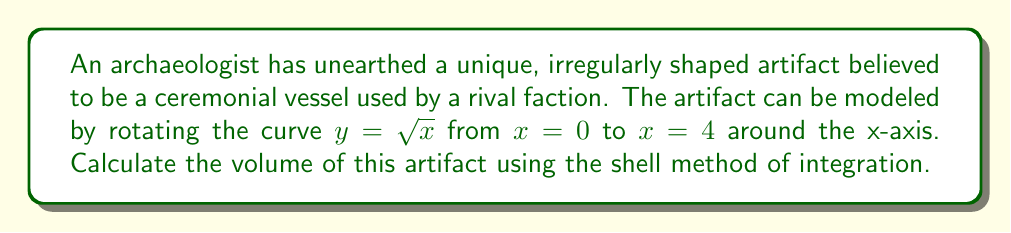Teach me how to tackle this problem. To solve this problem, we'll use the shell method of integration. The shell method is particularly useful for finding the volume of a solid of revolution when rotating around the y-axis or, in this case, the x-axis.

The formula for the shell method when rotating around the x-axis is:

$$V = 2\pi \int_a^b y \cdot x \, dy$$

Where $y$ is the radius of each shell and $x$ is the height of each shell.

Given information:
- Curve: $y = \sqrt{x}$
- Rotation: around the x-axis
- Limits: from $x = 0$ to $x = 4$

Steps:
1) First, we need to express $x$ in terms of $y$:
   $y = \sqrt{x}$
   $x = y^2$

2) Determine the limits of integration in terms of $y$:
   When $x = 0$, $y = \sqrt{0} = 0$
   When $x = 4$, $y = \sqrt{4} = 2$

3) Apply the shell method formula:
   $$V = 2\pi \int_0^2 y \cdot y^2 \, dy$$

4) Simplify the integrand:
   $$V = 2\pi \int_0^2 y^3 \, dy$$

5) Integrate:
   $$V = 2\pi \left[ \frac{y^4}{4} \right]_0^2$$

6) Evaluate the definite integral:
   $$V = 2\pi \left( \frac{2^4}{4} - \frac{0^4}{4} \right)$$
   $$V = 2\pi \left( \frac{16}{4} - 0 \right)$$
   $$V = 2\pi \cdot 4$$
   $$V = 8\pi$$

Therefore, the volume of the artifact is $8\pi$ cubic units.
Answer: $8\pi$ cubic units 